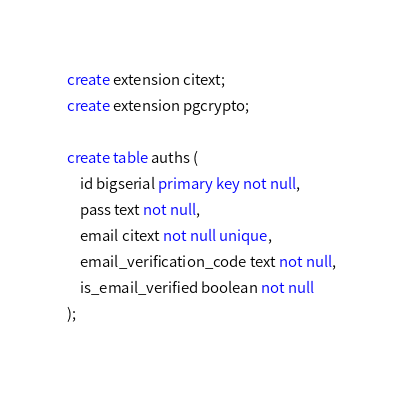Convert code to text. <code><loc_0><loc_0><loc_500><loc_500><_SQL_>create extension citext;
create extension pgcrypto;

create table auths (
    id bigserial primary key not null,
    pass text not null,
    email citext not null unique,
    email_verification_code text not null,
    is_email_verified boolean not null
);</code> 